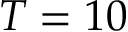Convert formula to latex. <formula><loc_0><loc_0><loc_500><loc_500>T = 1 0</formula> 